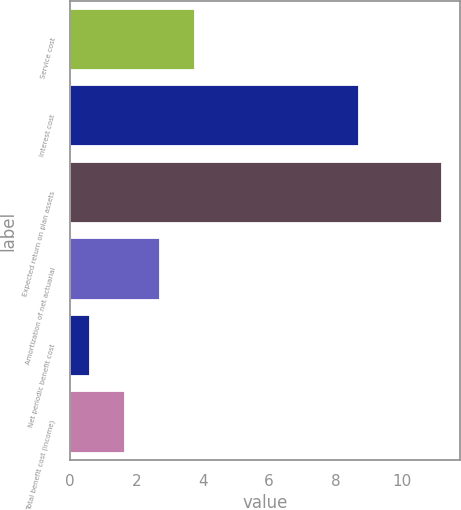Convert chart. <chart><loc_0><loc_0><loc_500><loc_500><bar_chart><fcel>Service cost<fcel>Interest cost<fcel>Expected return on plan assets<fcel>Amortization of net actuarial<fcel>Net periodic benefit cost<fcel>Total benefit cost (income)<nl><fcel>3.78<fcel>8.7<fcel>11.2<fcel>2.72<fcel>0.6<fcel>1.66<nl></chart> 